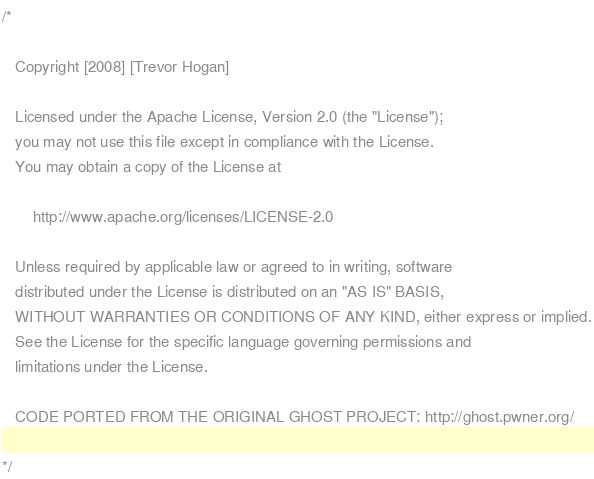<code> <loc_0><loc_0><loc_500><loc_500><_C++_>/*

   Copyright [2008] [Trevor Hogan]

   Licensed under the Apache License, Version 2.0 (the "License");
   you may not use this file except in compliance with the License.
   You may obtain a copy of the License at

       http://www.apache.org/licenses/LICENSE-2.0

   Unless required by applicable law or agreed to in writing, software
   distributed under the License is distributed on an "AS IS" BASIS,
   WITHOUT WARRANTIES OR CONDITIONS OF ANY KIND, either express or implied.
   See the License for the specific language governing permissions and
   limitations under the License.

   CODE PORTED FROM THE ORIGINAL GHOST PROJECT: http://ghost.pwner.org/

*/
</code> 